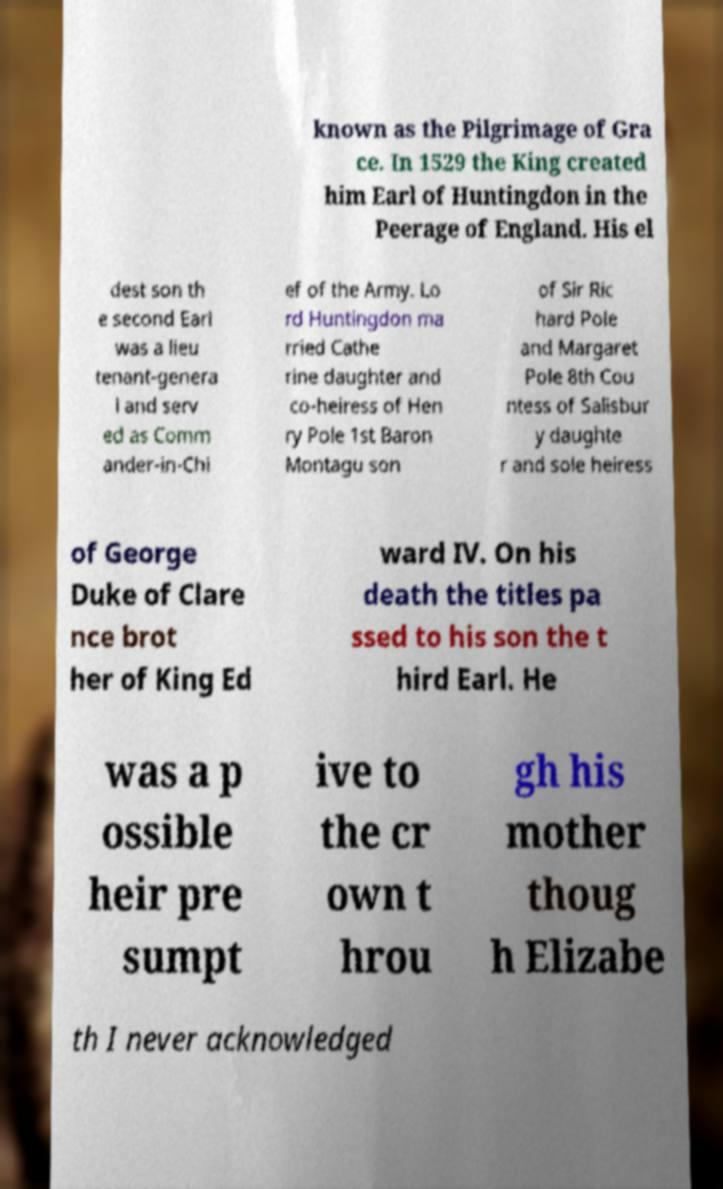Can you accurately transcribe the text from the provided image for me? known as the Pilgrimage of Gra ce. In 1529 the King created him Earl of Huntingdon in the Peerage of England. His el dest son th e second Earl was a lieu tenant-genera l and serv ed as Comm ander-in-Chi ef of the Army. Lo rd Huntingdon ma rried Cathe rine daughter and co-heiress of Hen ry Pole 1st Baron Montagu son of Sir Ric hard Pole and Margaret Pole 8th Cou ntess of Salisbur y daughte r and sole heiress of George Duke of Clare nce brot her of King Ed ward IV. On his death the titles pa ssed to his son the t hird Earl. He was a p ossible heir pre sumpt ive to the cr own t hrou gh his mother thoug h Elizabe th I never acknowledged 